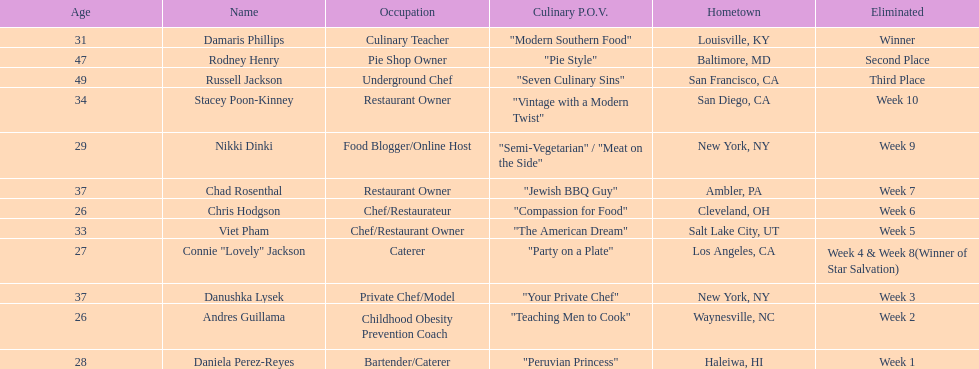On food network star's season 9, who was the initial participant to be eliminated? Daniela Perez-Reyes. 